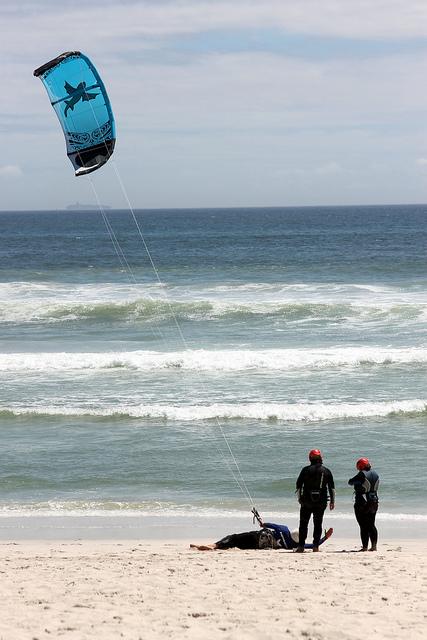Why is the man on the ground?
Quick response, please. Landing. Is this the beach?
Be succinct. Yes. How many people are standing up?
Concise answer only. 2. 